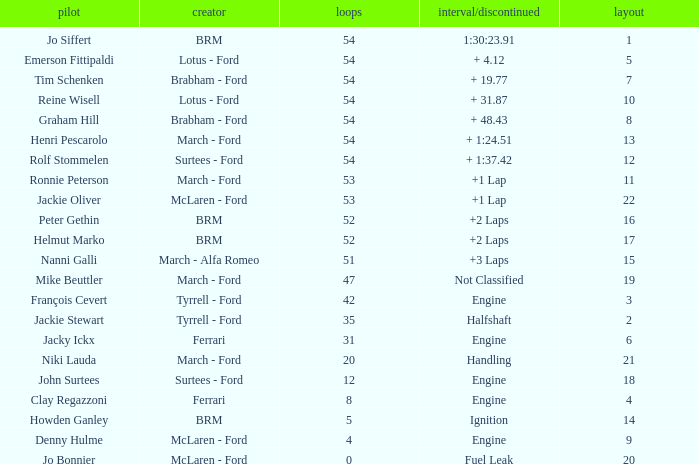What is the low grid that has brm and over 54 laps? None. 